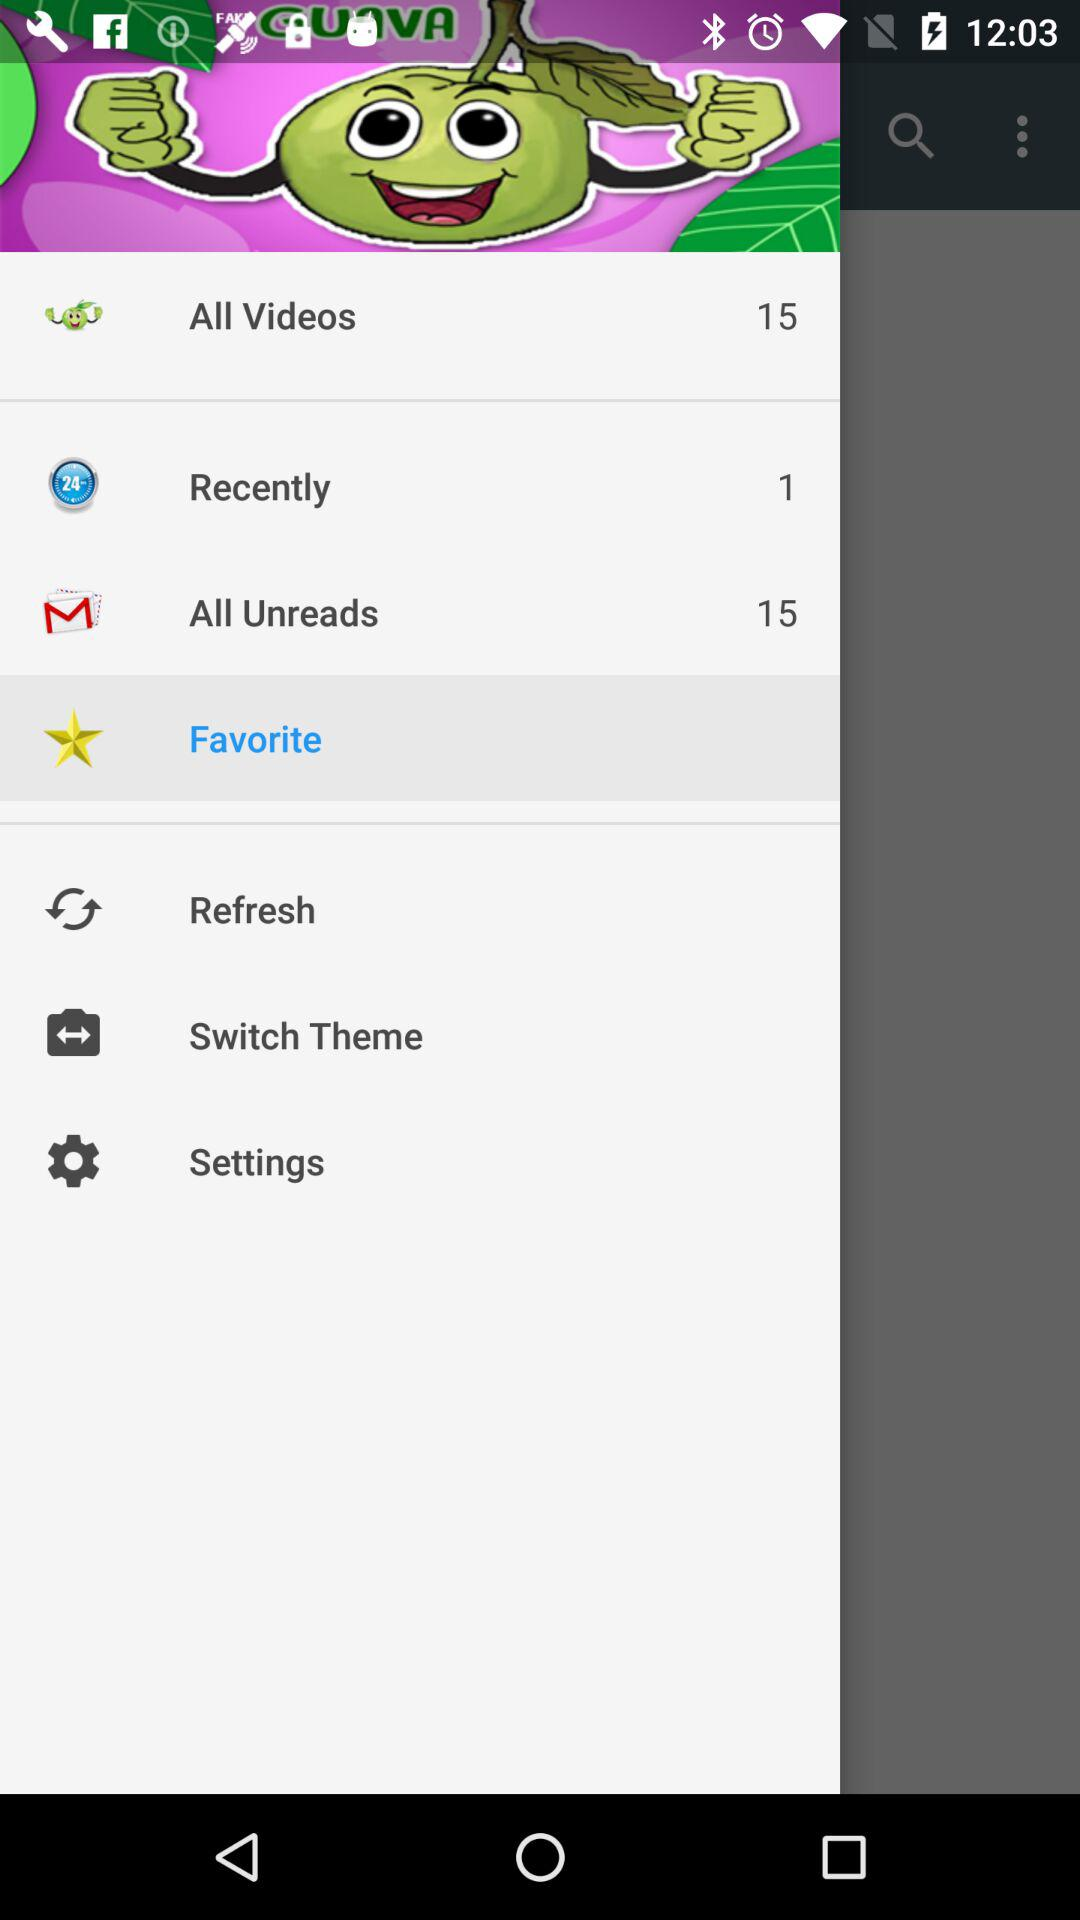How many items in "Recently" are there? There is 1 item in "Recently". 